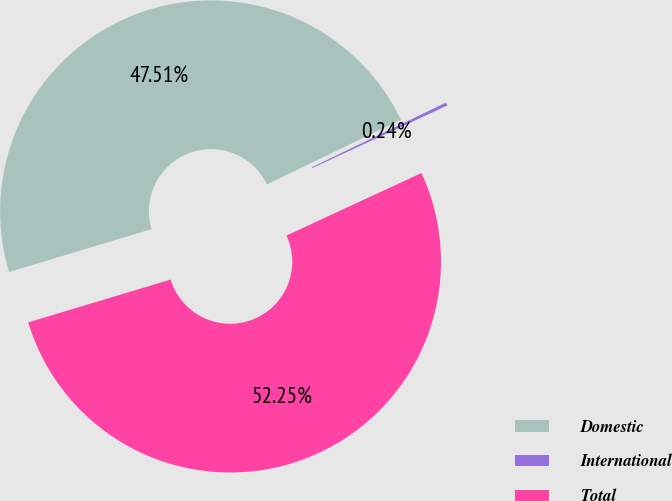Convert chart to OTSL. <chart><loc_0><loc_0><loc_500><loc_500><pie_chart><fcel>Domestic<fcel>International<fcel>Total<nl><fcel>47.51%<fcel>0.24%<fcel>52.26%<nl></chart> 